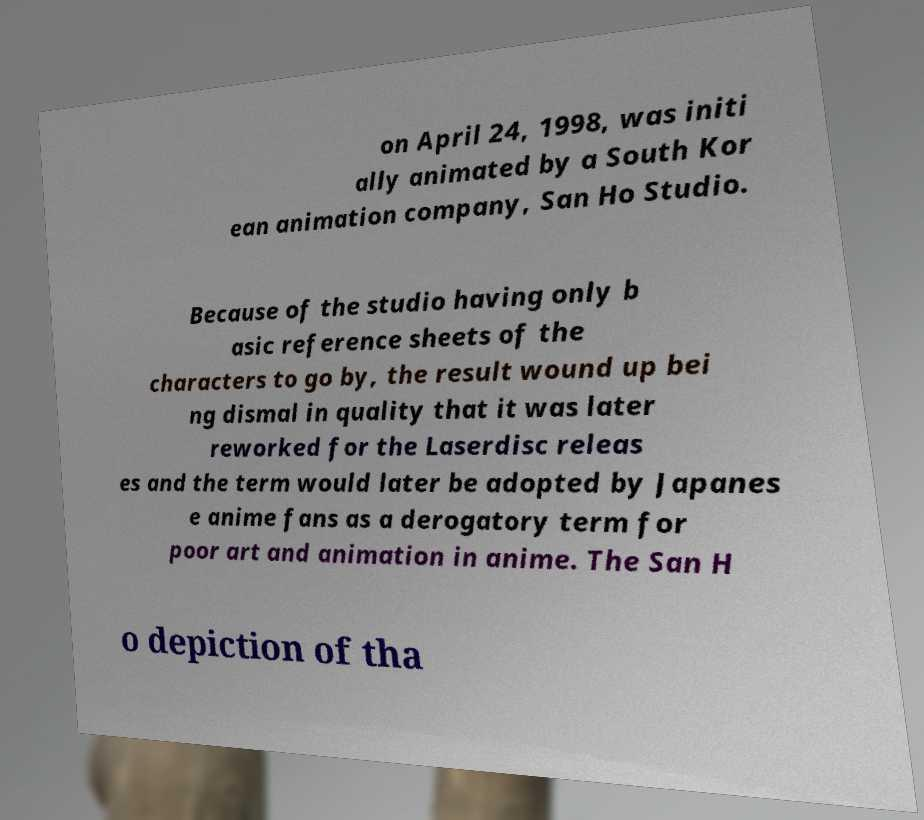Please identify and transcribe the text found in this image. on April 24, 1998, was initi ally animated by a South Kor ean animation company, San Ho Studio. Because of the studio having only b asic reference sheets of the characters to go by, the result wound up bei ng dismal in quality that it was later reworked for the Laserdisc releas es and the term would later be adopted by Japanes e anime fans as a derogatory term for poor art and animation in anime. The San H o depiction of tha 